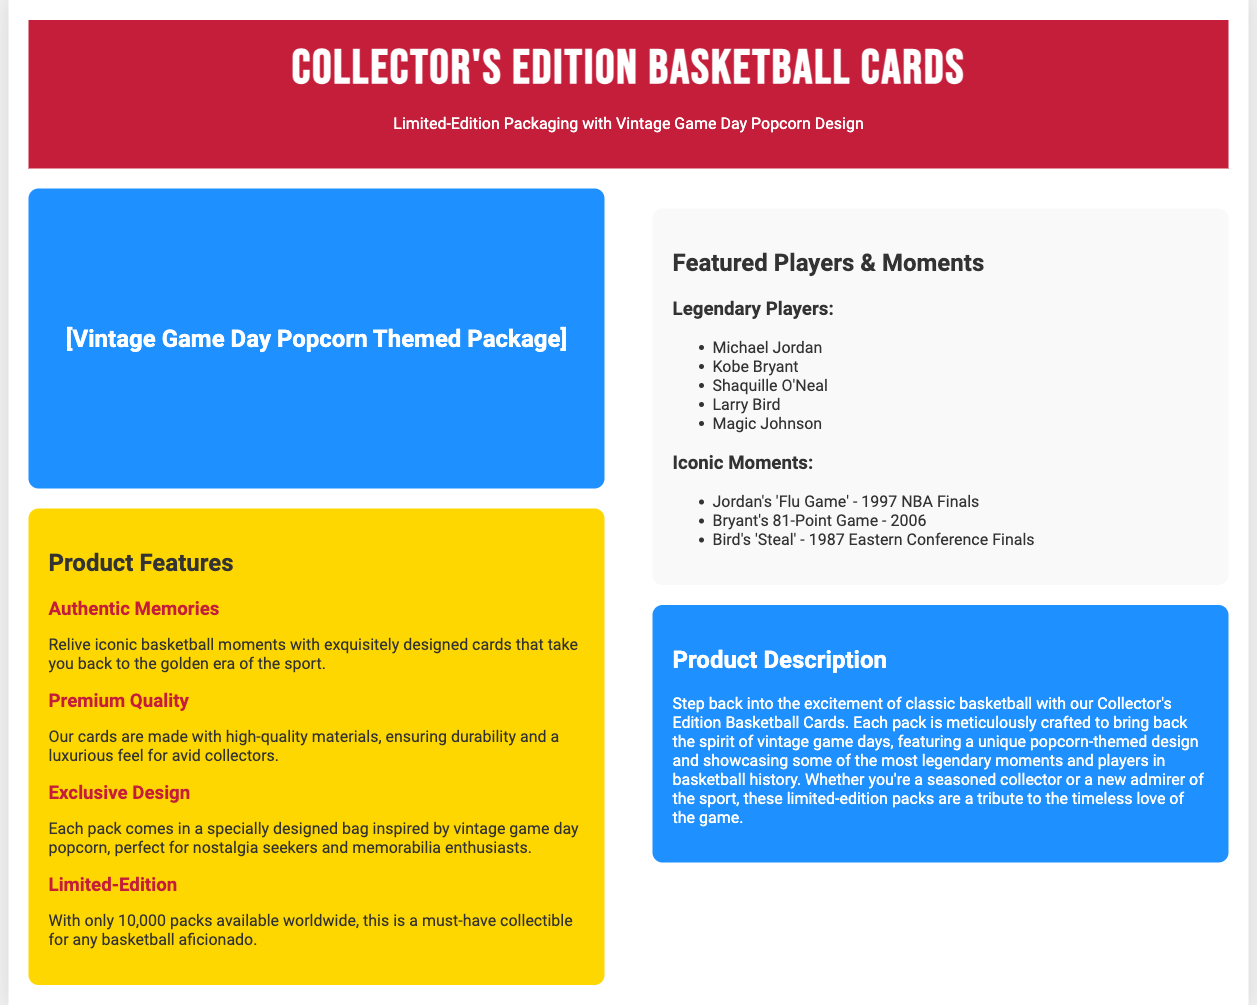What is the design theme of the packaging? The packaging features a vintage popcorn design, evoking nostalgic game day memories.
Answer: Vintage Game Day Popcorn How many packs are available worldwide? The document states that there are only 10,000 packs available for this limited-edition product.
Answer: 10,000 Which player is associated with the 'Flu Game'? The 'Flu Game' is famously associated with Michael Jordan, as highlighted in the iconic moments section.
Answer: Michael Jordan What quality is emphasized for the cards? The document mentions that the cards are made with high-quality materials, ensuring durability.
Answer: Premium Quality Who is listed as one of the legendary players? The document lists several players, including one who is iconic in basketball history, such as Kobe Bryant.
Answer: Kobe Bryant What year did Kobe Bryant score 81 points in a game? The document states that Kobe Bryant's 81-point game occurred in the year 2006.
Answer: 2006 What is the overall product description focused on? The product description emphasizes bringing back the nostalgia and excitement of classic basketball through collectible cards.
Answer: Vintage game days Which color is used for the header background? The document specifies that the header features a bold red color.
Answer: Red What is the main purpose of the Collector's Edition cards? The main purpose of offering these cards is serving as a tribute to the timeless love of the game.
Answer: Tribute to the game 